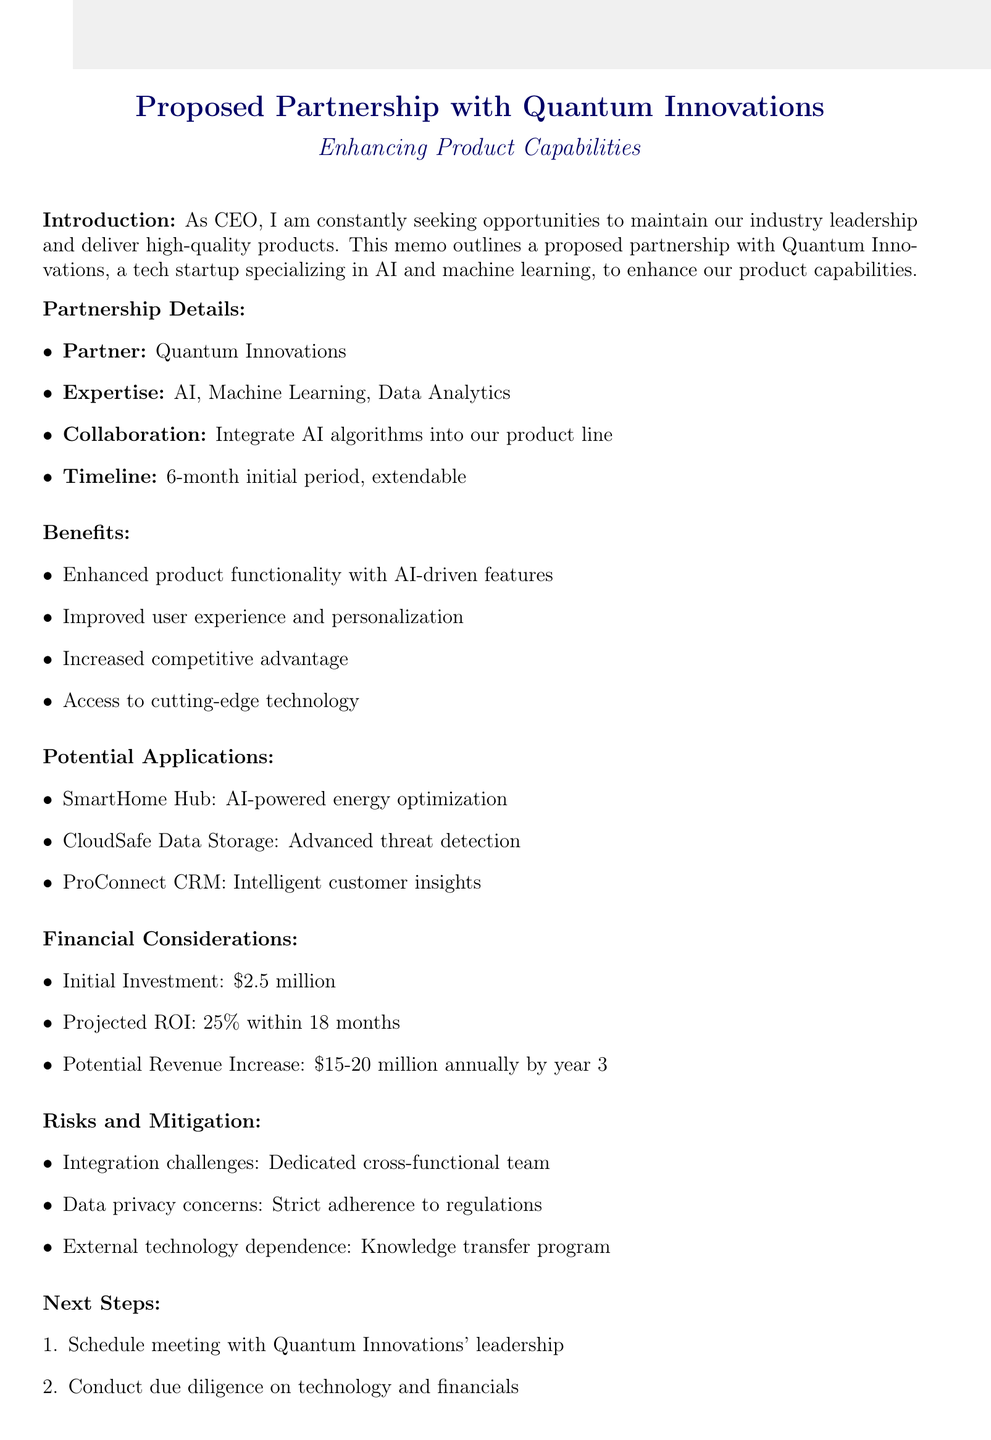What is the name of the partner company? The document states the partner company is Quantum Innovations.
Answer: Quantum Innovations What is the initial investment required for the partnership? The initial investment is explicitly mentioned in the financial considerations section of the document.
Answer: $2.5 million What expertise does Quantum Innovations have? The document lists the expertise of Quantum Innovations, which is pertinent information about the potential partner.
Answer: Artificial Intelligence, Machine Learning, Data Analytics What is the projected ROI within 18 months? The projected ROI is stated in the financial considerations section of the document.
Answer: 25% What is one potential application of the partnership mentioned in the memo? The document lists potential applications of the partnership, indicating specific products and their enhancements.
Answer: SmartHome Hub What is the duration of the proposed initial collaboration? The timeline for the collaboration is stated and is an essential detail regarding the partnership.
Answer: 6-month initial collaboration How will data privacy concerns be addressed? The memo provides specific mitigations for identified risks, including data privacy.
Answer: Strict adherence to GDPR and other data protection regulations What is the recommended next step after this partnership proposal? The document outlines the next steps required to move forward with the partnership, reflecting actionable recommendations.
Answer: Schedule meeting with Quantum Innovations' leadership team What is the potential revenue increase by year 3? The financial section of the memo specifies the estimated revenue increase we can expect from the partnership.
Answer: $15-20 million annually by year 3 